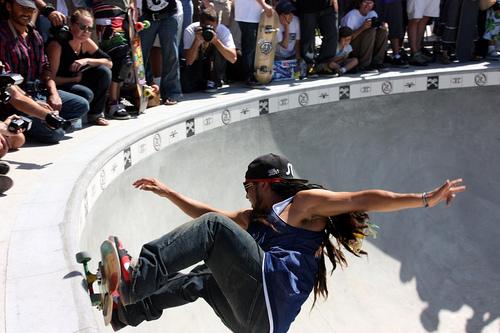Which wrist is the skateboarder wearing his bracelet?
Write a very short answer. Left. Is someone taking a picture of the skater?
Write a very short answer. Yes. Is this skater wearing his hat forward or backward?
Answer briefly. Backward. 